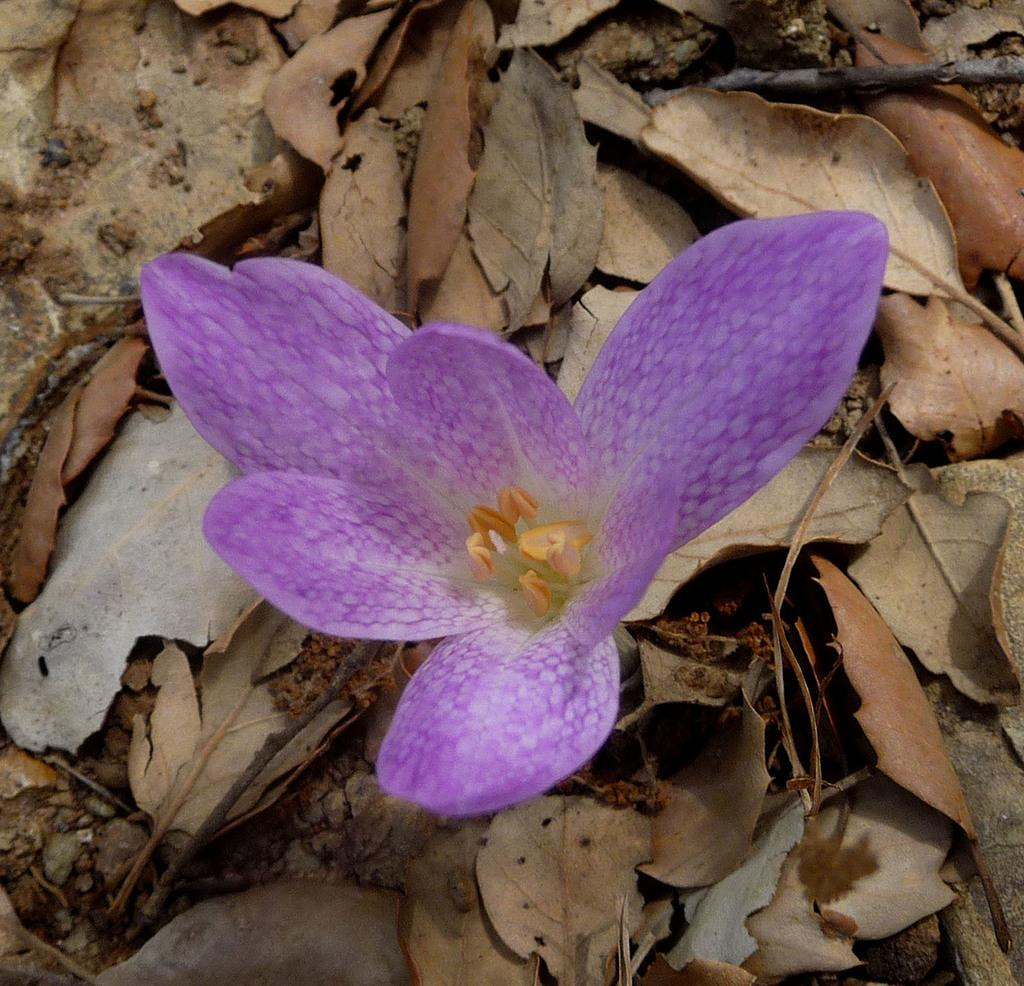What is the main subject of the picture? The main subject of the picture is a flower. Can you describe the color of the flower? The flower is purple in color. What else can be seen below the flower in the picture? There are dried leaves below the flower. What type of invention is being demonstrated in the picture? There is no invention being demonstrated in the picture; it features a purple flower with dried leaves below it. What news headline might be related to the flower in the picture? There is no news headline related to the flower in the picture; it is simply a photograph of a purple flower with dried leaves below it. 